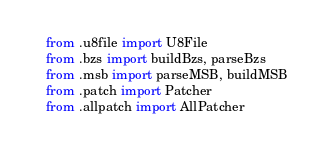<code> <loc_0><loc_0><loc_500><loc_500><_Python_>from .u8file import U8File
from .bzs import buildBzs, parseBzs
from .msb import parseMSB, buildMSB
from .patch import Patcher
from .allpatch import AllPatcher
</code> 